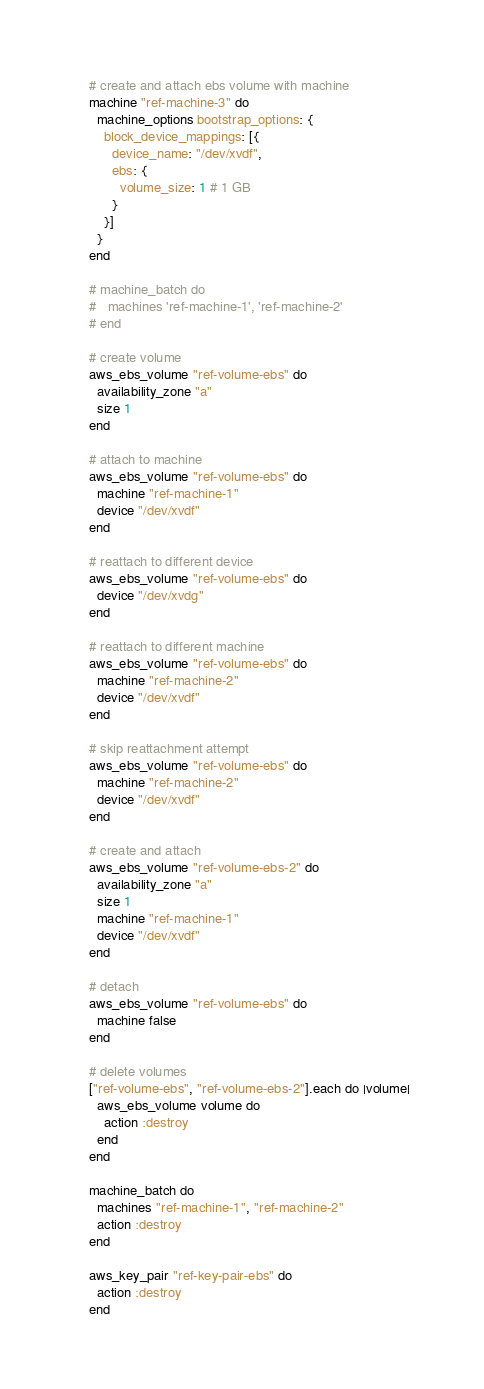<code> <loc_0><loc_0><loc_500><loc_500><_Ruby_># create and attach ebs volume with machine
machine "ref-machine-3" do
  machine_options bootstrap_options: {
    block_device_mappings: [{
      device_name: "/dev/xvdf",
      ebs: {
        volume_size: 1 # 1 GB
      }
    }]
  }
end

# machine_batch do
#   machines 'ref-machine-1', 'ref-machine-2'
# end

# create volume
aws_ebs_volume "ref-volume-ebs" do
  availability_zone "a"
  size 1
end

# attach to machine
aws_ebs_volume "ref-volume-ebs" do
  machine "ref-machine-1"
  device "/dev/xvdf"
end

# reattach to different device
aws_ebs_volume "ref-volume-ebs" do
  device "/dev/xvdg"
end

# reattach to different machine
aws_ebs_volume "ref-volume-ebs" do
  machine "ref-machine-2"
  device "/dev/xvdf"
end

# skip reattachment attempt
aws_ebs_volume "ref-volume-ebs" do
  machine "ref-machine-2"
  device "/dev/xvdf"
end

# create and attach
aws_ebs_volume "ref-volume-ebs-2" do
  availability_zone "a"
  size 1
  machine "ref-machine-1"
  device "/dev/xvdf"
end

# detach
aws_ebs_volume "ref-volume-ebs" do
  machine false
end

# delete volumes
["ref-volume-ebs", "ref-volume-ebs-2"].each do |volume|
  aws_ebs_volume volume do
    action :destroy
  end
end

machine_batch do
  machines "ref-machine-1", "ref-machine-2"
  action :destroy
end

aws_key_pair "ref-key-pair-ebs" do
  action :destroy
end
</code> 